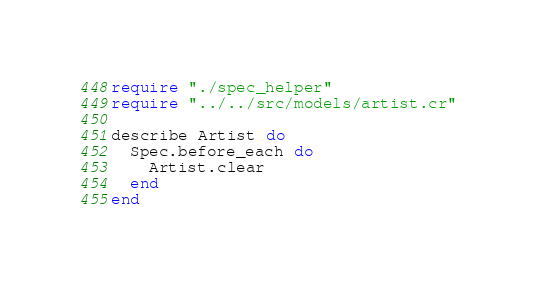Convert code to text. <code><loc_0><loc_0><loc_500><loc_500><_Crystal_>require "./spec_helper"
require "../../src/models/artist.cr"

describe Artist do
  Spec.before_each do
    Artist.clear
  end
end
</code> 